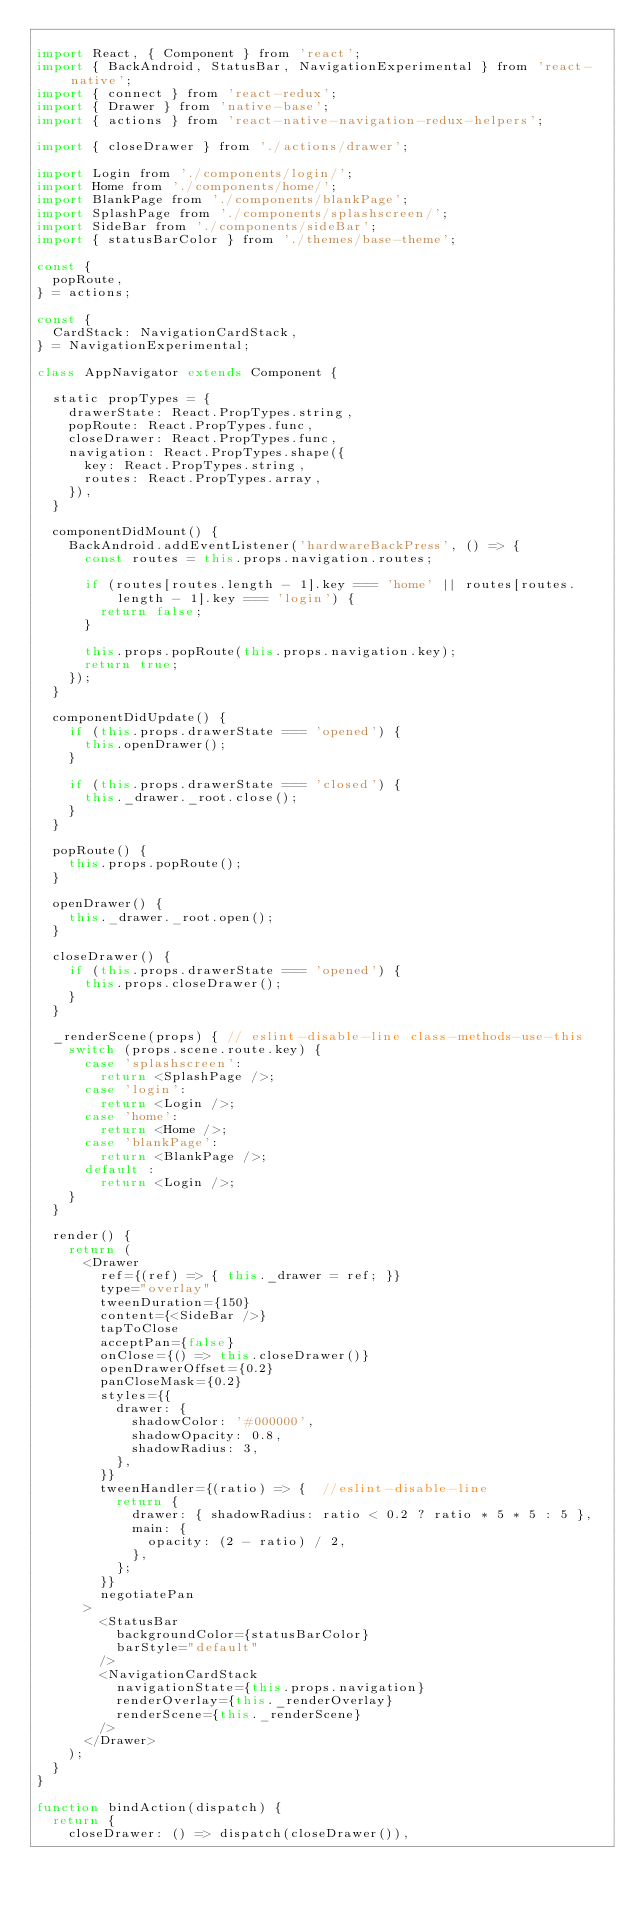<code> <loc_0><loc_0><loc_500><loc_500><_JavaScript_>
import React, { Component } from 'react';
import { BackAndroid, StatusBar, NavigationExperimental } from 'react-native';
import { connect } from 'react-redux';
import { Drawer } from 'native-base';
import { actions } from 'react-native-navigation-redux-helpers';

import { closeDrawer } from './actions/drawer';

import Login from './components/login/';
import Home from './components/home/';
import BlankPage from './components/blankPage';
import SplashPage from './components/splashscreen/';
import SideBar from './components/sideBar';
import { statusBarColor } from './themes/base-theme';

const {
  popRoute,
} = actions;

const {
  CardStack: NavigationCardStack,
} = NavigationExperimental;

class AppNavigator extends Component {

  static propTypes = {
    drawerState: React.PropTypes.string,
    popRoute: React.PropTypes.func,
    closeDrawer: React.PropTypes.func,
    navigation: React.PropTypes.shape({
      key: React.PropTypes.string,
      routes: React.PropTypes.array,
    }),
  }

  componentDidMount() {
    BackAndroid.addEventListener('hardwareBackPress', () => {
      const routes = this.props.navigation.routes;

      if (routes[routes.length - 1].key === 'home' || routes[routes.length - 1].key === 'login') {
        return false;
      }

      this.props.popRoute(this.props.navigation.key);
      return true;
    });
  }

  componentDidUpdate() {
    if (this.props.drawerState === 'opened') {
      this.openDrawer();
    }

    if (this.props.drawerState === 'closed') {
      this._drawer._root.close();
    }
  }

  popRoute() {
    this.props.popRoute();
  }

  openDrawer() {
    this._drawer._root.open();
  }

  closeDrawer() {
    if (this.props.drawerState === 'opened') {
      this.props.closeDrawer();
    }
  }

  _renderScene(props) { // eslint-disable-line class-methods-use-this
    switch (props.scene.route.key) {
      case 'splashscreen':
        return <SplashPage />;
      case 'login':
        return <Login />;
      case 'home':
        return <Home />;
      case 'blankPage':
        return <BlankPage />;
      default :
        return <Login />;
    }
  }

  render() {
    return (
      <Drawer
        ref={(ref) => { this._drawer = ref; }}
        type="overlay"
        tweenDuration={150}
        content={<SideBar />}
        tapToClose
        acceptPan={false}
        onClose={() => this.closeDrawer()}
        openDrawerOffset={0.2}
        panCloseMask={0.2}
        styles={{
          drawer: {
            shadowColor: '#000000',
            shadowOpacity: 0.8,
            shadowRadius: 3,
          },
        }}
        tweenHandler={(ratio) => {  //eslint-disable-line
          return {
            drawer: { shadowRadius: ratio < 0.2 ? ratio * 5 * 5 : 5 },
            main: {
              opacity: (2 - ratio) / 2,
            },
          };
        }}
        negotiatePan
      >
        <StatusBar
          backgroundColor={statusBarColor}
          barStyle="default"
        />
        <NavigationCardStack
          navigationState={this.props.navigation}
          renderOverlay={this._renderOverlay}
          renderScene={this._renderScene}
        />
      </Drawer>
    );
  }
}

function bindAction(dispatch) {
  return {
    closeDrawer: () => dispatch(closeDrawer()),</code> 